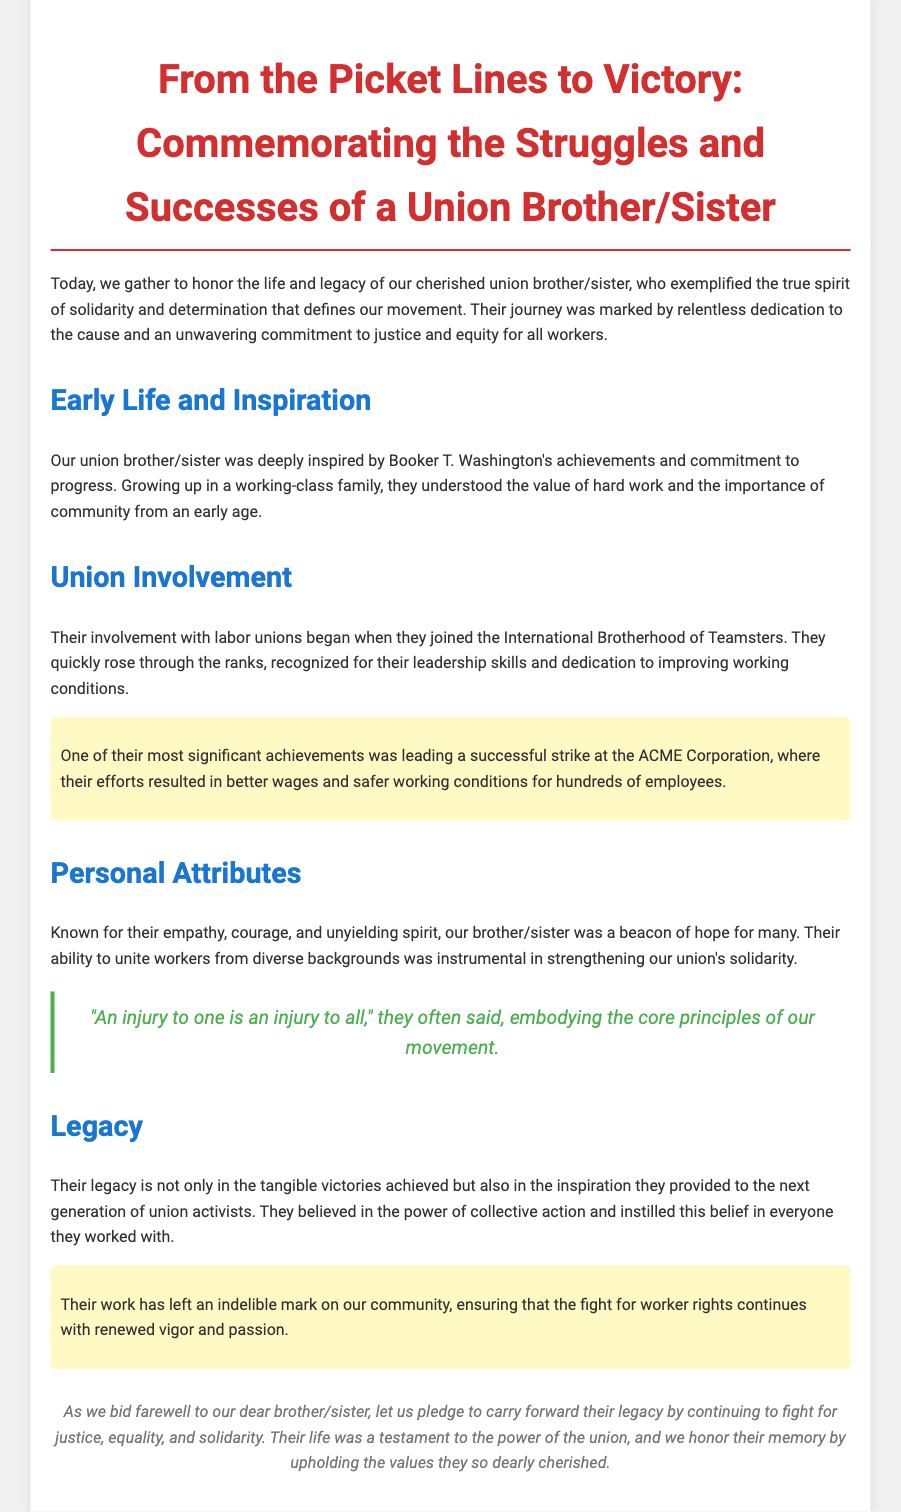What was the title of the eulogy? The title of the eulogy is clearly stated at the top of the document.
Answer: From the Picket Lines to Victory: Commemorating the Struggles and Successes of a Union Brother/Sister Who was the union brother/sister inspired by? The eulogy mentions that the union brother/sister was inspired by a prominent figure in their early life.
Answer: Booker T. Washington Which union did the individual join? The document states which labor union the individual was first involved with.
Answer: International Brotherhood of Teamsters What significant achievement is highlighted in the eulogy? A crucial contribution made by the union brother/sister during their involvement is noted.
Answer: Leading a successful strike at the ACME Corporation What was one of their personal attributes? The eulogy describes several qualities of the individual; one is mentioned specifically.
Answer: Empathy What quote did the individual often say? A specific phrase that embodies their beliefs is included in the document.
Answer: An injury to one is an injury to all What did the individual believe in? The document outlines a principle that was central to the individual’s activism.
Answer: Power of collective action What did they instill in the next generation? The individual’s influence on future activists is referenced in the eulogy.
Answer: Belief in the power of collective action 